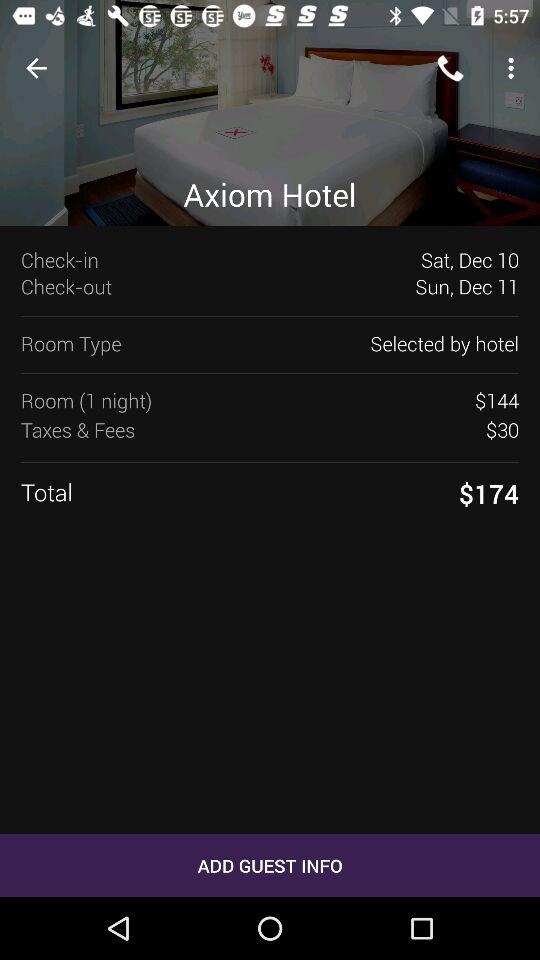What is the amount of "Taxes & Fees"? The amount of "Taxes & Fees" is $30. 